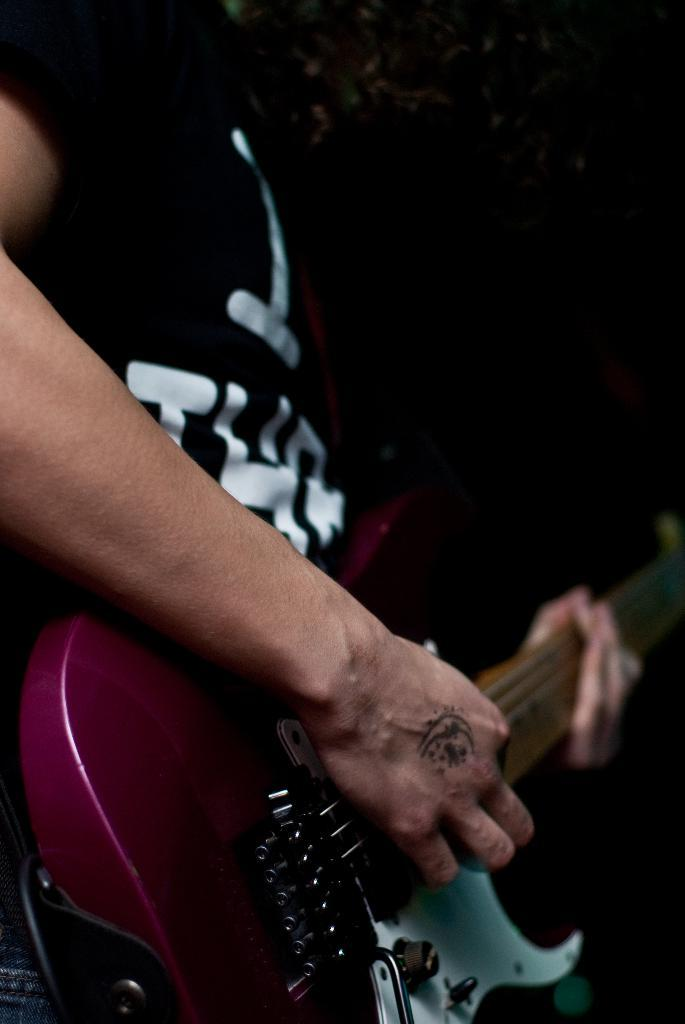What is the main subject of the image? There is a person in the image. What is the person doing in the image? The person is playing a musical instrument. Can you describe the background of the image? The background of the image is dark. How much wealth does the person in the image possess? There is no information about the person's wealth in the image. Is there a yard visible in the image? There is no yard present in the image; it only shows a person playing a musical instrument with a dark background. 